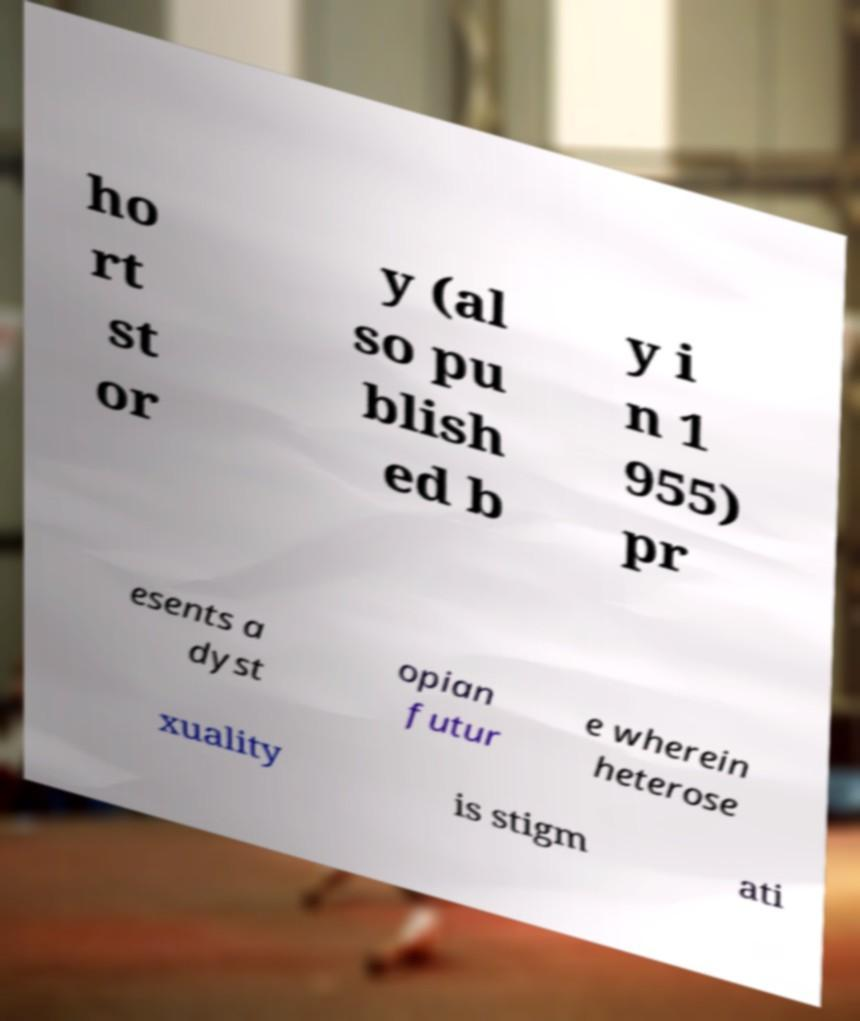What messages or text are displayed in this image? I need them in a readable, typed format. ho rt st or y (al so pu blish ed b y i n 1 955) pr esents a dyst opian futur e wherein heterose xuality is stigm ati 